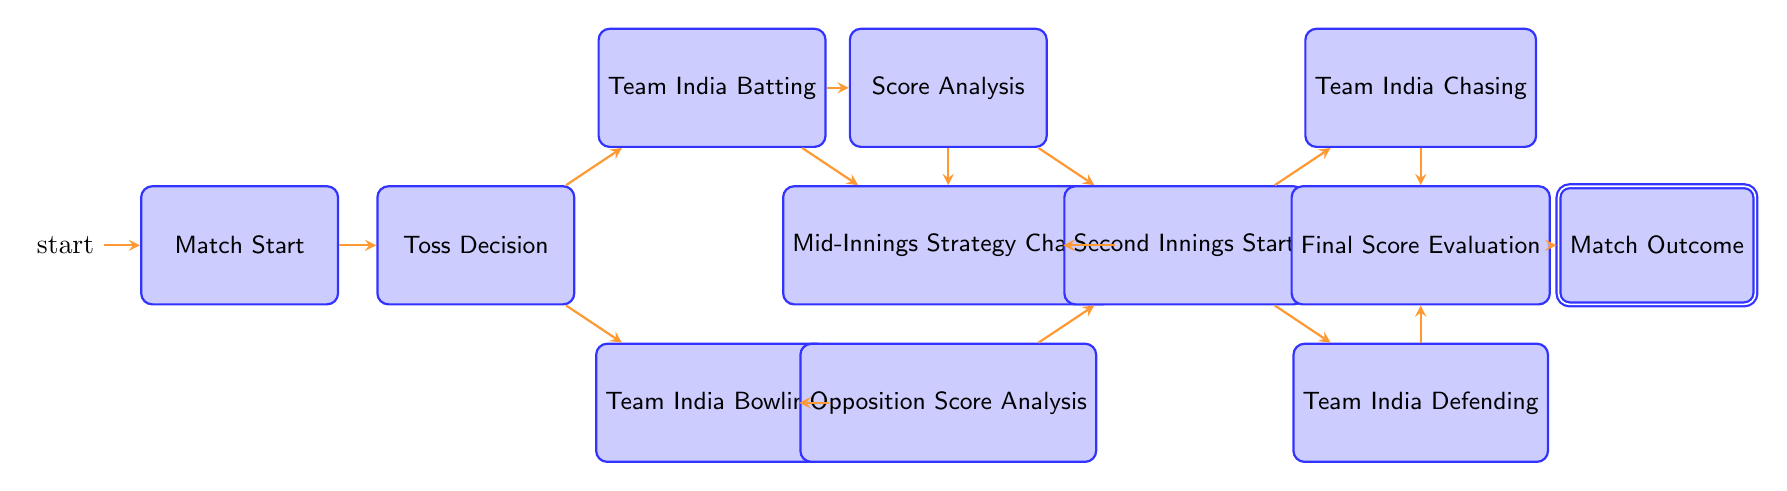What is the starting node of the diagram? The diagram begins at the "Match Start" node, indicating the beginning of the cricket match.
Answer: Match Start How many transitions are there from the "Toss Decision" node? The "Toss Decision" node has two possible transitions: "Team India Batting" and "Team India Bowling." Therefore, there are 2 transitions.
Answer: 2 What is the first node reached after "Team India Batting"? After "Team India Batting," the next possible node is "Score Analysis." This transition reflects analyzing the score as the team bats.
Answer: Score Analysis Which node follows "Mid-Innings Strategy Change"? The "Mid-Innings Strategy Change" node leads to the "Second Innings Start" node, as it implies a strategic adjustment that occurs before the second innings.
Answer: Second Innings Start What is the outcome if the Indian team is defending? If the Indian team is in the "Team India Defending" state, it transitions to "Final Score Evaluation," where the match's outcome will be assessed.
Answer: Final Score Evaluation What are the two possible states after the "Second Innings Start"? After the "Second Innings Start," the two possible states are "Team India Chasing" and "Team India Defending," indicating whether India is trying to win or protect their lead.
Answer: Team India Chasing, Team India Defending How many nodes are in the diagram? The diagram contains 11 nodes, including all states representing various stages of the match. Counting them gives us a total of 11 nodes.
Answer: 11 What is the terminal or final node of the diagram? The terminal node, indicating the end of the process and concluding the match outcomes, is "Match Outcome." This node signifies the ultimate conclusion of the game.
Answer: Match Outcome What is the relationship between "Opposition Score Analysis" and "Second Innings Start"? The "Opposition Score Analysis" node directly transitions to the "Second Innings Start" node, meaning that analyzing the opponent's score leads to the beginning of the second innings.
Answer: Second Innings Start What happens after "Final Score Evaluation"? After "Final Score Evaluation," the process concludes with reaching the "Match Outcome" node, determining the end result of the match based on the score assessed.
Answer: Match Outcome 